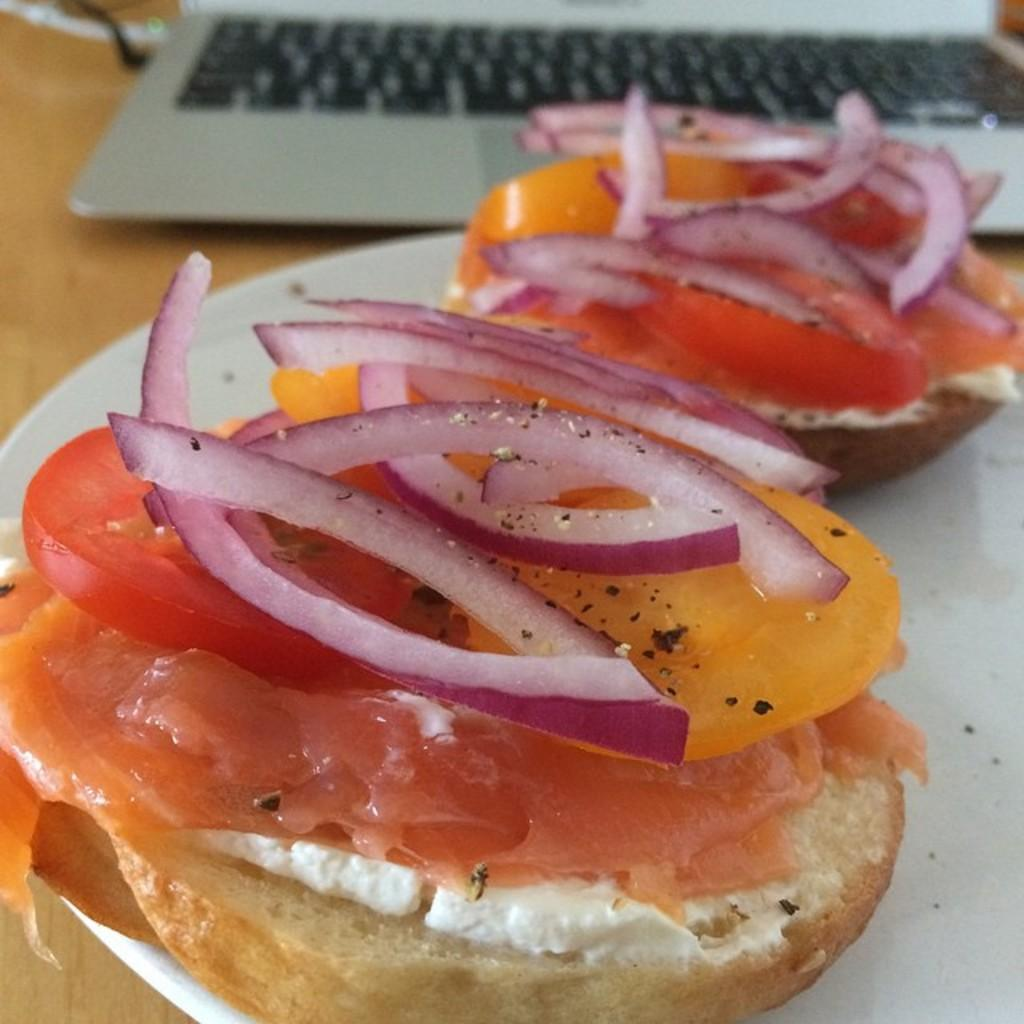What is on the plate that is visible in the image? There are food items on a plate in the image. What electronic device can be seen on a table in the image? There is a laptop on a table in the image. What type of judge is sitting next to the laptop in the image? There is no judge present in the image; it only features food items on a plate and a laptop on a table. How many sticks are visible in the image? There are no sticks visible in the image. 